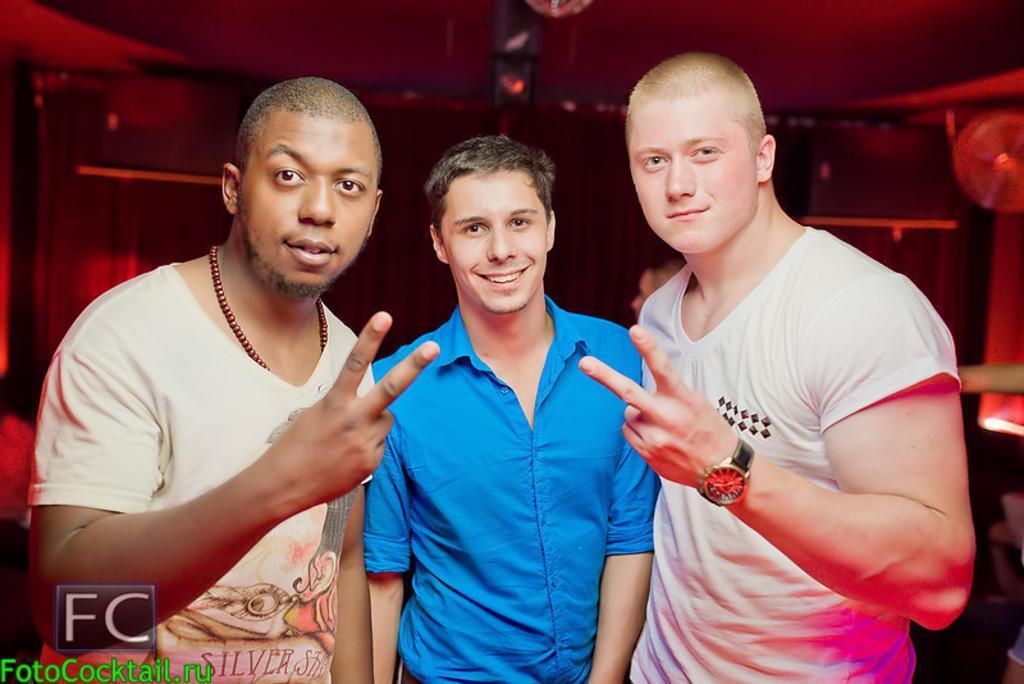How would you summarize this image in a sentence or two? There are three men standing and smiling. In the background, that looks like an object. I can see the watermark on the image. 